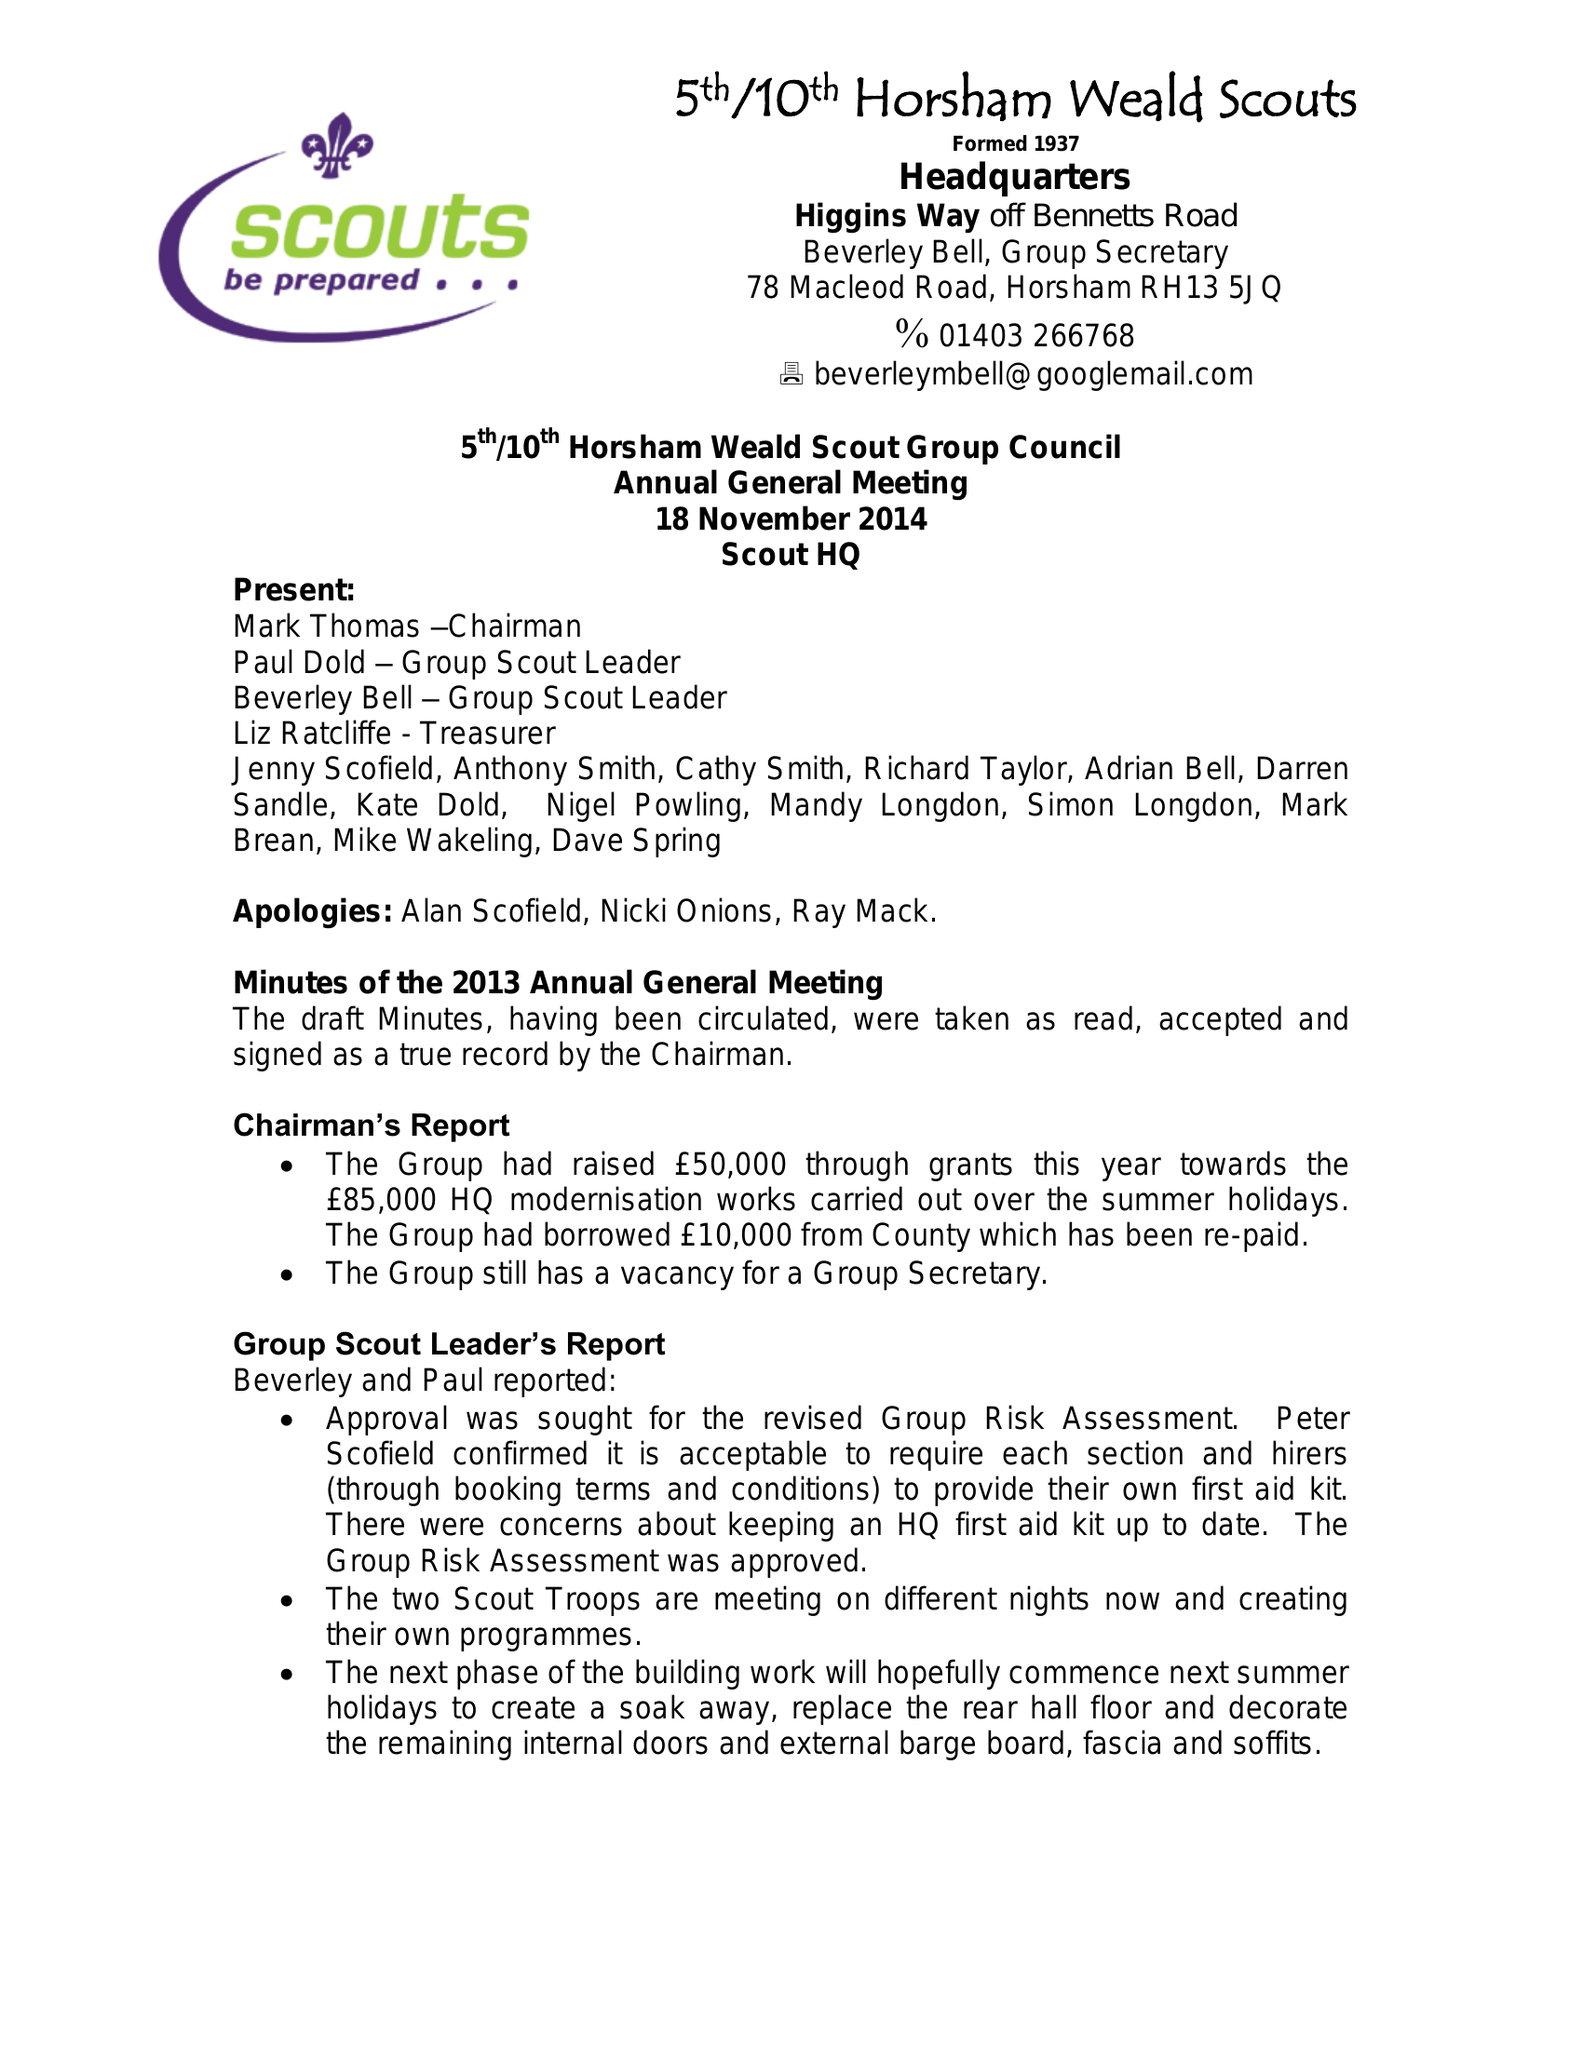What is the value for the charity_name?
Answer the question using a single word or phrase. 5th/10th Horsham Scout Group 